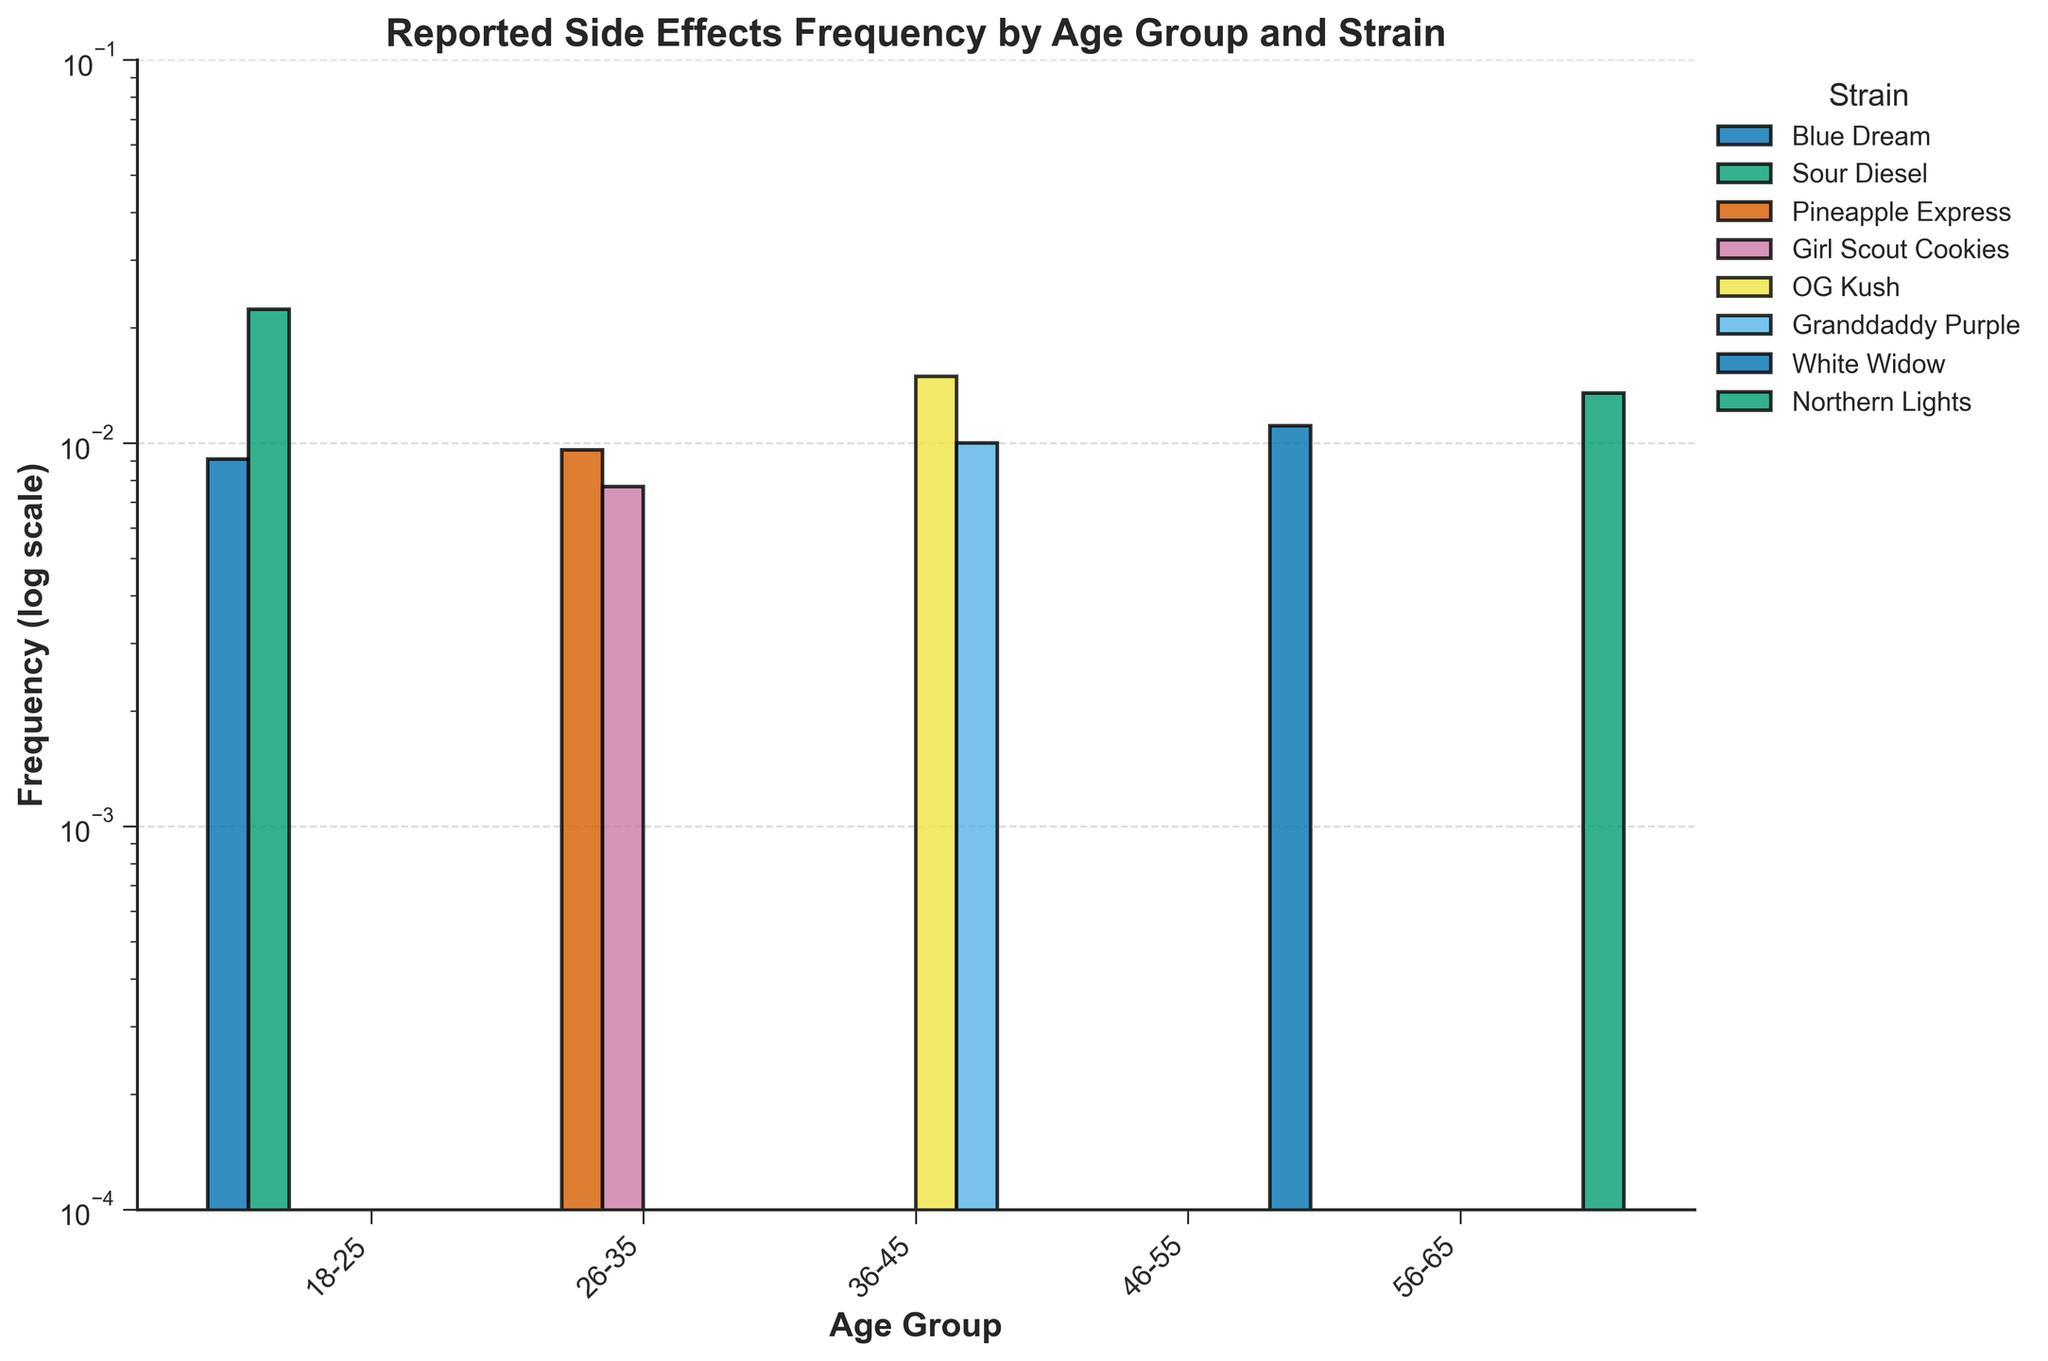Which age group reports Dry Mouth most frequently? We find the frequency of Dry Mouth reported by each age group. The highest bar representing Dry Mouth is observed for age group 56-65 Northern Lights.
Answer: Age group 56-65 Which strain has the highest reported frequency of Anxiety for the 18-25 age group? We look at the bars for the 18-25 age group and check which strain has the highest bar for Anxiety. Blue Dream has the frequency of 0.0025, whereas Sour Diesel does not have Anxiety reported. Hence, Blue Dream has the highest reported frequency for Anxiety.
Answer: Blue Dream Which side effect is reported more frequently by the 26-35 age group when consuming Pineapple Express: Headache or Anxiety? We compare the frequency of Headache and Anxiety for Pineapple Express in the 26-35 age group. Headache has a frequency of 0.0034, while Anxiety has a frequency of 0.0062. Therefore, Anxiety is reported more frequently.
Answer: Anxiety Which strain results in the most frequent side effect for the age group 36-45? We compare the frequencies of all side effects reported for 36-45 age group strains. The highest bar is for OG Kush - Dry Mouth with 0.0071 frequency.
Answer: OG Kush Which side effect has the overall highest frequency across all age groups and strains? We compare all the bars across all age groups and strains to see which one has the highest value. The highest is 0.0145 for Paranoia with Sour Diesel in the 18-25 age group.
Answer: Paranoia How many unique strains are analyzed in the plot? We count the unique bars present in the figure. The strains are Blue Dream, Sour Diesel, Pineapple Express, Girl Scout Cookies, OG Kush, Granddaddy Purple, White Widow, and Northern Lights.
Answer: 8 For the 46-55 age group, which strain has the lowest total frequency of reported side effects? We sum the frequencies for White Widow, which are 0.0029, 0.0021, and 0.0061. There is only one strain.
Answer: 0.0021 for Anxiety What is the frequency difference between the highest and lowest reported side effects for the 26-35 age group? We compare the highest (Pineapple Express, Anxiety, 0.0062) and the lowest (Girl Scout Cookies, Drowsiness, 0.0021) frequencies among the 26-35 group. The difference is 0.0062 - 0.0021 = 0.0041.
Answer: 0.0041 Which age group reports side effects from Pineapple Express less frequently: 18-25 or 26-35? Pineapple Express appears only for 26-35 with reported frequencies, but none for 18-25. Hence, 18-25 reports less.
Answer: 18-25 Which strain has the most balanced (least variation) side effect frequencies across all age groups? By observing the plot, the strain whose bars have the least vertical difference between highest and lowest side effect frequency has the most balanced distribution. White Widow has relatively close frequencies of 0.0021, 0.0029, and 0.0061.
Answer: White Widow 